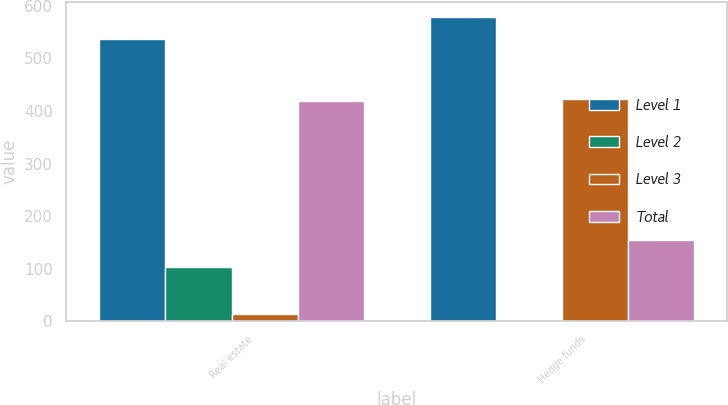<chart> <loc_0><loc_0><loc_500><loc_500><stacked_bar_chart><ecel><fcel>Real estate<fcel>Hedge funds<nl><fcel>Level 1<fcel>537<fcel>578<nl><fcel>Level 2<fcel>104<fcel>2<nl><fcel>Level 3<fcel>14<fcel>422<nl><fcel>Total<fcel>419<fcel>154<nl></chart> 